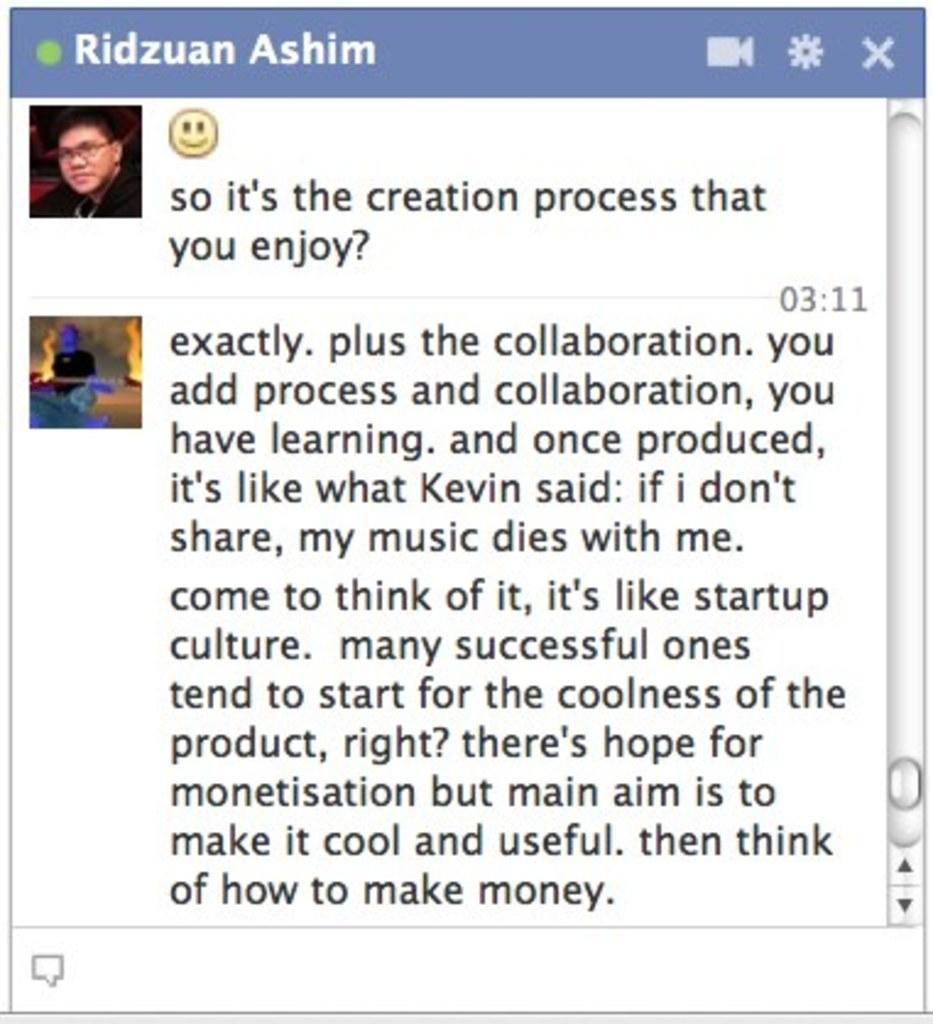Could you give a brief overview of what you see in this image? In this image we can see a screen shot of a chat, and some matter is written on it, there are two images at the left top. 